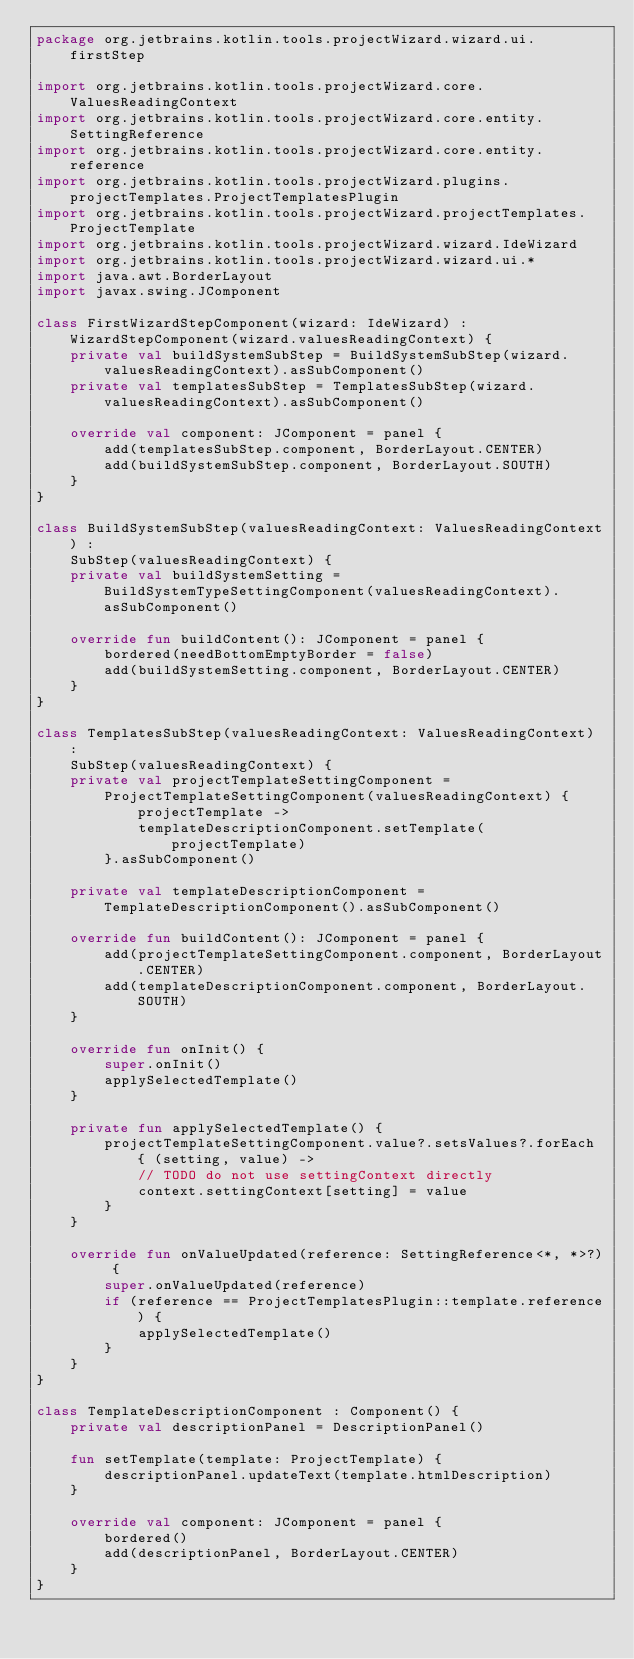Convert code to text. <code><loc_0><loc_0><loc_500><loc_500><_Kotlin_>package org.jetbrains.kotlin.tools.projectWizard.wizard.ui.firstStep

import org.jetbrains.kotlin.tools.projectWizard.core.ValuesReadingContext
import org.jetbrains.kotlin.tools.projectWizard.core.entity.SettingReference
import org.jetbrains.kotlin.tools.projectWizard.core.entity.reference
import org.jetbrains.kotlin.tools.projectWizard.plugins.projectTemplates.ProjectTemplatesPlugin
import org.jetbrains.kotlin.tools.projectWizard.projectTemplates.ProjectTemplate
import org.jetbrains.kotlin.tools.projectWizard.wizard.IdeWizard
import org.jetbrains.kotlin.tools.projectWizard.wizard.ui.*
import java.awt.BorderLayout
import javax.swing.JComponent

class FirstWizardStepComponent(wizard: IdeWizard) : WizardStepComponent(wizard.valuesReadingContext) {
    private val buildSystemSubStep = BuildSystemSubStep(wizard.valuesReadingContext).asSubComponent()
    private val templatesSubStep = TemplatesSubStep(wizard.valuesReadingContext).asSubComponent()

    override val component: JComponent = panel {
        add(templatesSubStep.component, BorderLayout.CENTER)
        add(buildSystemSubStep.component, BorderLayout.SOUTH)
    }
}

class BuildSystemSubStep(valuesReadingContext: ValuesReadingContext) :
    SubStep(valuesReadingContext) {
    private val buildSystemSetting = BuildSystemTypeSettingComponent(valuesReadingContext).asSubComponent()

    override fun buildContent(): JComponent = panel {
        bordered(needBottomEmptyBorder = false)
        add(buildSystemSetting.component, BorderLayout.CENTER)
    }
}

class TemplatesSubStep(valuesReadingContext: ValuesReadingContext) :
    SubStep(valuesReadingContext) {
    private val projectTemplateSettingComponent =
        ProjectTemplateSettingComponent(valuesReadingContext) { projectTemplate ->
            templateDescriptionComponent.setTemplate(projectTemplate)
        }.asSubComponent()

    private val templateDescriptionComponent = TemplateDescriptionComponent().asSubComponent()

    override fun buildContent(): JComponent = panel {
        add(projectTemplateSettingComponent.component, BorderLayout.CENTER)
        add(templateDescriptionComponent.component, BorderLayout.SOUTH)
    }

    override fun onInit() {
        super.onInit()
        applySelectedTemplate()
    }

    private fun applySelectedTemplate() {
        projectTemplateSettingComponent.value?.setsValues?.forEach { (setting, value) ->
            // TODO do not use settingContext directly
            context.settingContext[setting] = value
        }
    }

    override fun onValueUpdated(reference: SettingReference<*, *>?) {
        super.onValueUpdated(reference)
        if (reference == ProjectTemplatesPlugin::template.reference) {
            applySelectedTemplate()
        }
    }
}

class TemplateDescriptionComponent : Component() {
    private val descriptionPanel = DescriptionPanel()

    fun setTemplate(template: ProjectTemplate) {
        descriptionPanel.updateText(template.htmlDescription)
    }

    override val component: JComponent = panel {
        bordered()
        add(descriptionPanel, BorderLayout.CENTER)
    }
}</code> 